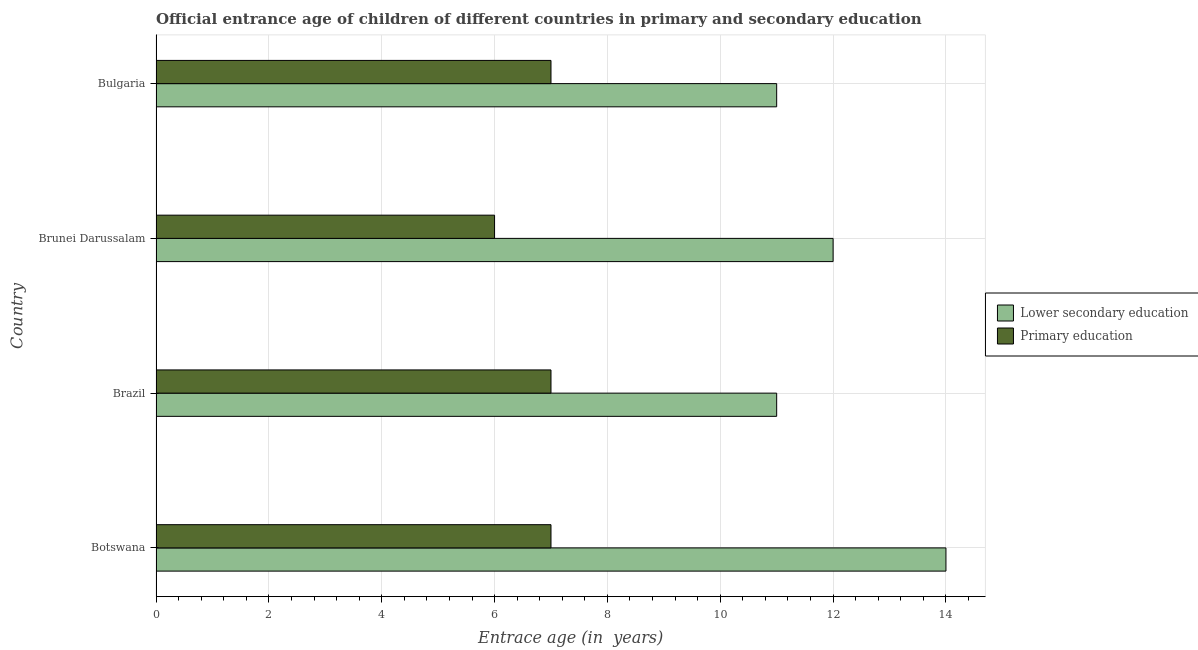How many different coloured bars are there?
Provide a succinct answer. 2. Are the number of bars per tick equal to the number of legend labels?
Provide a succinct answer. Yes. Are the number of bars on each tick of the Y-axis equal?
Give a very brief answer. Yes. How many bars are there on the 4th tick from the top?
Your answer should be very brief. 2. What is the label of the 2nd group of bars from the top?
Make the answer very short. Brunei Darussalam. What is the entrance age of children in lower secondary education in Brunei Darussalam?
Ensure brevity in your answer.  12. Across all countries, what is the maximum entrance age of children in lower secondary education?
Give a very brief answer. 14. Across all countries, what is the minimum entrance age of children in lower secondary education?
Your answer should be compact. 11. In which country was the entrance age of children in lower secondary education maximum?
Provide a short and direct response. Botswana. In which country was the entrance age of children in lower secondary education minimum?
Your answer should be compact. Brazil. What is the total entrance age of children in lower secondary education in the graph?
Your response must be concise. 48. What is the difference between the entrance age of children in lower secondary education in Brazil and the entrance age of chiildren in primary education in Brunei Darussalam?
Offer a terse response. 5. What is the difference between the entrance age of children in lower secondary education and entrance age of chiildren in primary education in Brunei Darussalam?
Your answer should be very brief. 6. In how many countries, is the entrance age of chiildren in primary education greater than 0.4 years?
Offer a very short reply. 4. What is the ratio of the entrance age of children in lower secondary education in Brazil to that in Brunei Darussalam?
Your answer should be very brief. 0.92. Is the entrance age of chiildren in primary education in Brazil less than that in Brunei Darussalam?
Provide a succinct answer. No. What is the difference between the highest and the second highest entrance age of chiildren in primary education?
Offer a very short reply. 0. What is the difference between the highest and the lowest entrance age of chiildren in primary education?
Keep it short and to the point. 1. Is the sum of the entrance age of chiildren in primary education in Botswana and Bulgaria greater than the maximum entrance age of children in lower secondary education across all countries?
Your response must be concise. No. What does the 2nd bar from the top in Bulgaria represents?
Give a very brief answer. Lower secondary education. What does the 2nd bar from the bottom in Botswana represents?
Offer a very short reply. Primary education. Does the graph contain any zero values?
Offer a terse response. No. Does the graph contain grids?
Ensure brevity in your answer.  Yes. What is the title of the graph?
Your answer should be compact. Official entrance age of children of different countries in primary and secondary education. What is the label or title of the X-axis?
Your answer should be very brief. Entrace age (in  years). What is the Entrace age (in  years) of Primary education in Botswana?
Your answer should be very brief. 7. What is the Entrace age (in  years) of Lower secondary education in Brazil?
Offer a terse response. 11. What is the Entrace age (in  years) of Primary education in Brazil?
Your response must be concise. 7. What is the Entrace age (in  years) of Lower secondary education in Brunei Darussalam?
Offer a terse response. 12. What is the Entrace age (in  years) of Primary education in Bulgaria?
Provide a short and direct response. 7. Across all countries, what is the maximum Entrace age (in  years) in Lower secondary education?
Your response must be concise. 14. Across all countries, what is the maximum Entrace age (in  years) of Primary education?
Your response must be concise. 7. Across all countries, what is the minimum Entrace age (in  years) in Primary education?
Make the answer very short. 6. What is the total Entrace age (in  years) in Lower secondary education in the graph?
Give a very brief answer. 48. What is the difference between the Entrace age (in  years) in Lower secondary education in Botswana and that in Bulgaria?
Offer a terse response. 3. What is the difference between the Entrace age (in  years) of Primary education in Botswana and that in Bulgaria?
Offer a terse response. 0. What is the difference between the Entrace age (in  years) of Primary education in Brazil and that in Brunei Darussalam?
Offer a very short reply. 1. What is the difference between the Entrace age (in  years) of Lower secondary education in Brazil and that in Bulgaria?
Offer a terse response. 0. What is the difference between the Entrace age (in  years) in Primary education in Brazil and that in Bulgaria?
Give a very brief answer. 0. What is the difference between the Entrace age (in  years) of Lower secondary education in Botswana and the Entrace age (in  years) of Primary education in Brazil?
Give a very brief answer. 7. What is the difference between the Entrace age (in  years) of Lower secondary education in Botswana and the Entrace age (in  years) of Primary education in Brunei Darussalam?
Ensure brevity in your answer.  8. What is the difference between the Entrace age (in  years) of Lower secondary education in Botswana and the Entrace age (in  years) of Primary education in Bulgaria?
Give a very brief answer. 7. What is the difference between the Entrace age (in  years) of Lower secondary education in Brazil and the Entrace age (in  years) of Primary education in Bulgaria?
Your response must be concise. 4. What is the difference between the Entrace age (in  years) of Lower secondary education in Brunei Darussalam and the Entrace age (in  years) of Primary education in Bulgaria?
Provide a succinct answer. 5. What is the average Entrace age (in  years) in Primary education per country?
Offer a terse response. 6.75. What is the difference between the Entrace age (in  years) of Lower secondary education and Entrace age (in  years) of Primary education in Bulgaria?
Provide a short and direct response. 4. What is the ratio of the Entrace age (in  years) of Lower secondary education in Botswana to that in Brazil?
Offer a terse response. 1.27. What is the ratio of the Entrace age (in  years) of Primary education in Botswana to that in Brazil?
Provide a short and direct response. 1. What is the ratio of the Entrace age (in  years) of Lower secondary education in Botswana to that in Brunei Darussalam?
Keep it short and to the point. 1.17. What is the ratio of the Entrace age (in  years) in Lower secondary education in Botswana to that in Bulgaria?
Your response must be concise. 1.27. What is the ratio of the Entrace age (in  years) of Primary education in Botswana to that in Bulgaria?
Your answer should be compact. 1. What is the ratio of the Entrace age (in  years) in Lower secondary education in Brazil to that in Brunei Darussalam?
Offer a very short reply. 0.92. What is the ratio of the Entrace age (in  years) in Primary education in Brazil to that in Brunei Darussalam?
Make the answer very short. 1.17. What is the ratio of the Entrace age (in  years) in Lower secondary education in Brunei Darussalam to that in Bulgaria?
Offer a very short reply. 1.09. What is the difference between the highest and the second highest Entrace age (in  years) in Lower secondary education?
Offer a very short reply. 2. What is the difference between the highest and the lowest Entrace age (in  years) of Primary education?
Your answer should be very brief. 1. 